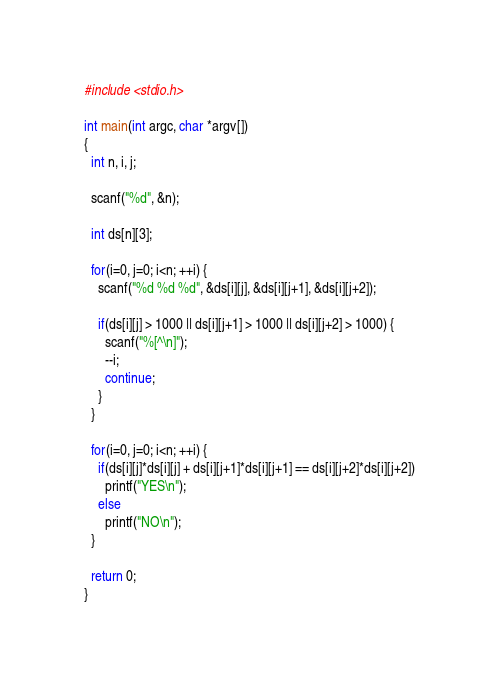<code> <loc_0><loc_0><loc_500><loc_500><_C_>#include <stdio.h>

int main(int argc, char *argv[])
{
  int n, i, j;

  scanf("%d", &n);

  int ds[n][3];

  for(i=0, j=0; i<n; ++i) {
    scanf("%d %d %d", &ds[i][j], &ds[i][j+1], &ds[i][j+2]);

    if(ds[i][j] > 1000 || ds[i][j+1] > 1000 || ds[i][j+2] > 1000) {
      scanf("%[^\n]");
      --i;
      continue;
    }
  }

  for(i=0, j=0; i<n; ++i) {
    if(ds[i][j]*ds[i][j] + ds[i][j+1]*ds[i][j+1] == ds[i][j+2]*ds[i][j+2])
      printf("YES\n");
    else
      printf("NO\n");
  }

  return 0;
}</code> 